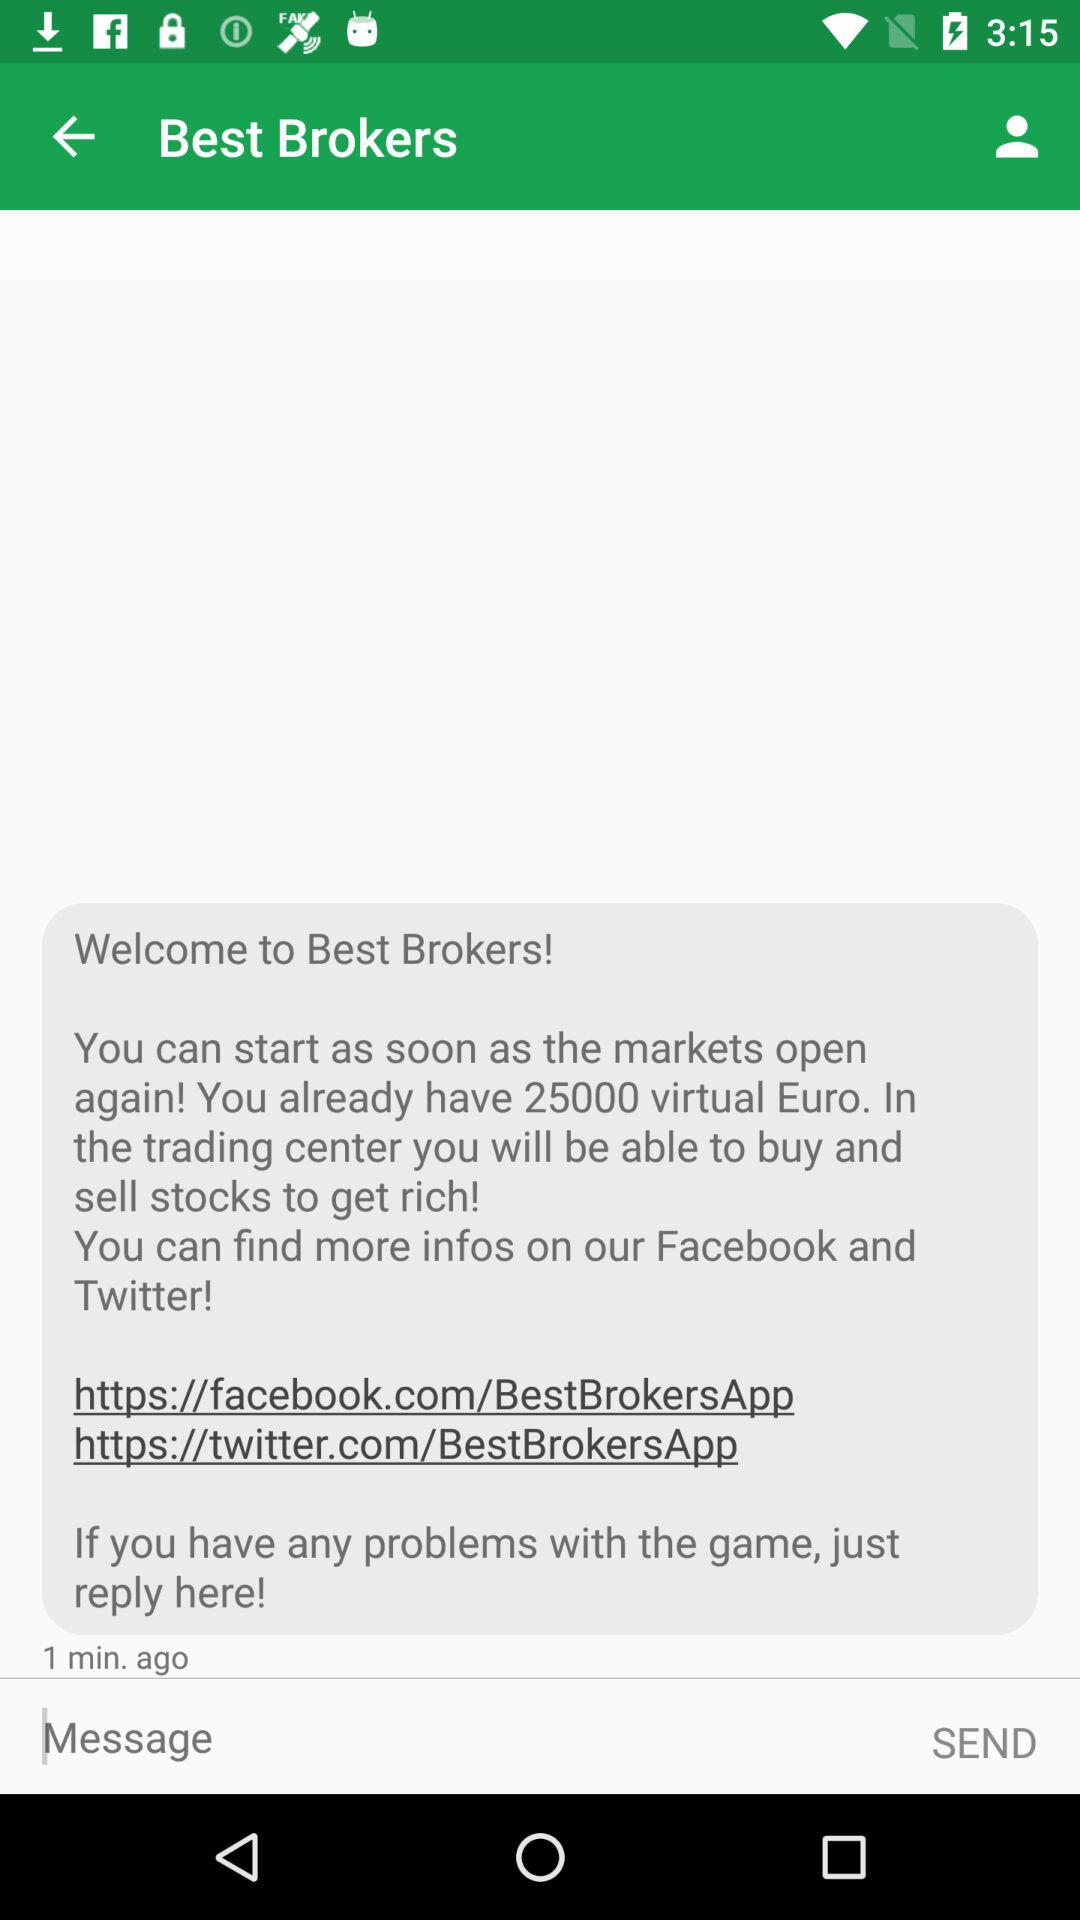How many minutes ago was the last message?
Answer the question using a single word or phrase. 1 